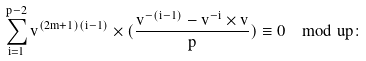Convert formula to latex. <formula><loc_0><loc_0><loc_500><loc_500>\sum _ { i = 1 } ^ { p - 2 } v ^ { ( 2 m + 1 ) ( i - 1 ) } \times ( \frac { v ^ { - ( i - 1 ) } - v ^ { - i } \times v } { p } ) \equiv 0 \mod u p \colon</formula> 